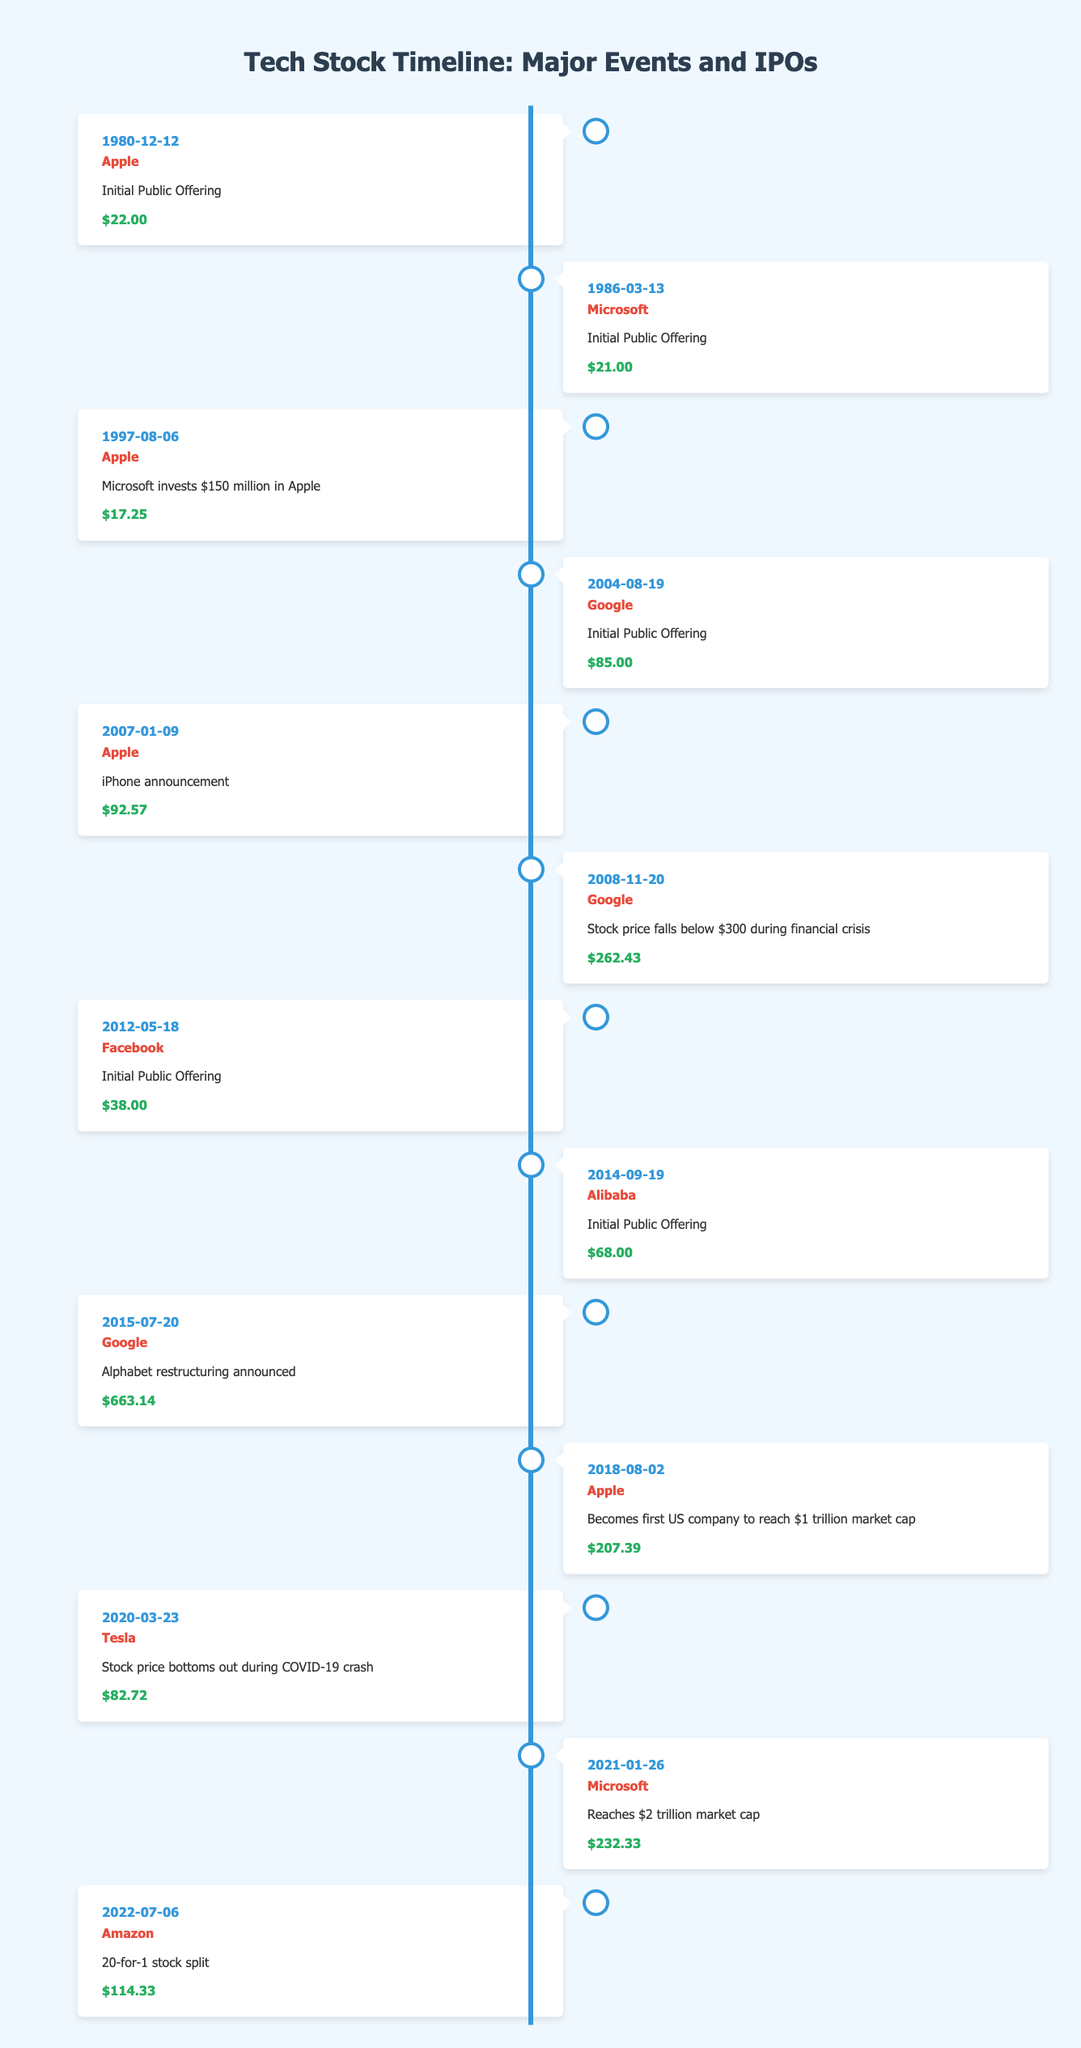What was the stock price of Apple during its Initial Public Offering? The table shows that Apple had its Initial Public Offering on December 12, 1980, with a stock price of $22.00.
Answer: $22.00 Which company had a stock price of $38.00 during its Initial Public Offering? According to the table, Facebook had its Initial Public Offering on May 18, 2012, with a stock price of $38.00.
Answer: Facebook Did Google stock fall below $300 during the financial crisis? The table indicates that on November 20, 2008, Google's stock price fell to $262.43, which is indeed below $300.
Answer: Yes What is the percentage increase in Apple's stock price from its Initial Public Offering to the iPhone announcement? Apple's stock price at its Initial Public Offering was $22.00, and at the iPhone announcement, it was $92.57. The percentage increase is calculated as [(92.57 - 22.00) / 22.00] * 100, which equals approximately 320.77%.
Answer: 320.77% Which company reached a $2 trillion market cap on January 26, 2021? The timeline lists that Microsoft reached a $2 trillion market cap on that date.
Answer: Microsoft What was the stock price of Tesla at its lowest point during the COVID-19 crash? The table indicates that Tesla's stock price bottomed out at $82.72 on March 23, 2020, during the COVID-19 crash.
Answer: $82.72 Calculate the difference in stock price between Google's IPO and its price during the financial crisis. Google's stock price during its IPO on August 19, 2004, was $85.00. During the financial crisis on November 20, 2008, the price was $262.43. The difference is 262.43 - 85.00 = $177.43.
Answer: $177.43 On which date did Apple become the first US company to reach a $1 trillion market cap? The table specifies that Apple reached this milestone on August 2, 2018.
Answer: August 2, 2018 Did Alibaba have a stock price below $68.00 following its Initial Public Offering? The table states that Alibaba's Initial Public Offering was on September 19, 2014, at a price of $68.00. As there are no later data points for Alibaba in the table, it's unclear without further data if its price dropped below this value after the IPO.
Answer: Cannot determine 